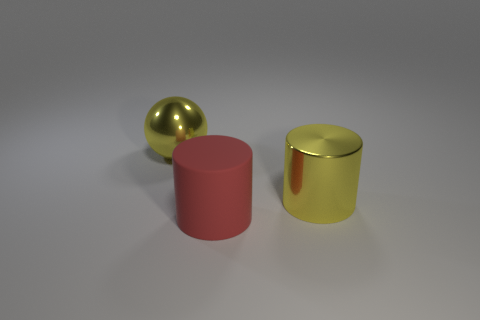Add 1 yellow objects. How many objects exist? 4 Subtract all red cylinders. How many cylinders are left? 1 Subtract 1 cylinders. How many cylinders are left? 1 Subtract all cylinders. How many objects are left? 1 Subtract all brown spheres. Subtract all red cylinders. How many spheres are left? 1 Subtract all gray cubes. How many yellow cylinders are left? 1 Subtract all cyan objects. Subtract all big objects. How many objects are left? 0 Add 1 metallic balls. How many metallic balls are left? 2 Add 1 red rubber cylinders. How many red rubber cylinders exist? 2 Subtract 1 yellow balls. How many objects are left? 2 